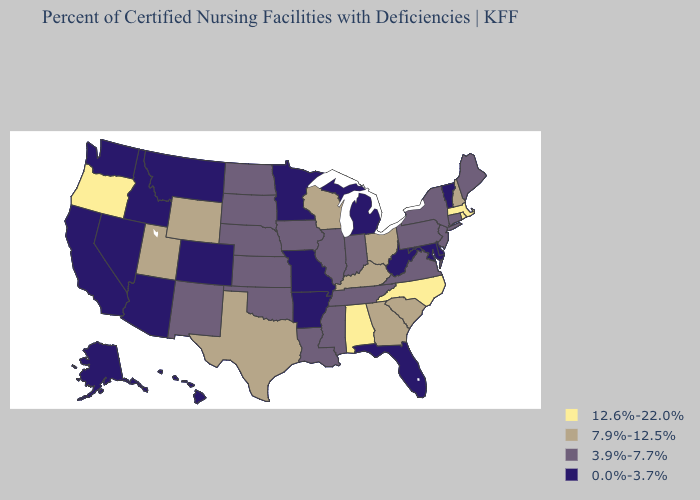What is the highest value in the Northeast ?
Write a very short answer. 12.6%-22.0%. Does Texas have the lowest value in the USA?
Write a very short answer. No. Name the states that have a value in the range 7.9%-12.5%?
Short answer required. Georgia, Kentucky, New Hampshire, Ohio, South Carolina, Texas, Utah, Wisconsin, Wyoming. What is the value of Alabama?
Concise answer only. 12.6%-22.0%. Name the states that have a value in the range 3.9%-7.7%?
Short answer required. Connecticut, Illinois, Indiana, Iowa, Kansas, Louisiana, Maine, Mississippi, Nebraska, New Jersey, New Mexico, New York, North Dakota, Oklahoma, Pennsylvania, South Dakota, Tennessee, Virginia. What is the highest value in states that border Ohio?
Write a very short answer. 7.9%-12.5%. What is the highest value in the South ?
Be succinct. 12.6%-22.0%. Name the states that have a value in the range 3.9%-7.7%?
Give a very brief answer. Connecticut, Illinois, Indiana, Iowa, Kansas, Louisiana, Maine, Mississippi, Nebraska, New Jersey, New Mexico, New York, North Dakota, Oklahoma, Pennsylvania, South Dakota, Tennessee, Virginia. Which states have the lowest value in the USA?
Quick response, please. Alaska, Arizona, Arkansas, California, Colorado, Delaware, Florida, Hawaii, Idaho, Maryland, Michigan, Minnesota, Missouri, Montana, Nevada, Vermont, Washington, West Virginia. What is the highest value in the MidWest ?
Write a very short answer. 7.9%-12.5%. Which states hav the highest value in the South?
Keep it brief. Alabama, North Carolina. Is the legend a continuous bar?
Write a very short answer. No. What is the value of Rhode Island?
Keep it brief. 12.6%-22.0%. What is the value of North Carolina?
Write a very short answer. 12.6%-22.0%. Name the states that have a value in the range 0.0%-3.7%?
Be succinct. Alaska, Arizona, Arkansas, California, Colorado, Delaware, Florida, Hawaii, Idaho, Maryland, Michigan, Minnesota, Missouri, Montana, Nevada, Vermont, Washington, West Virginia. 